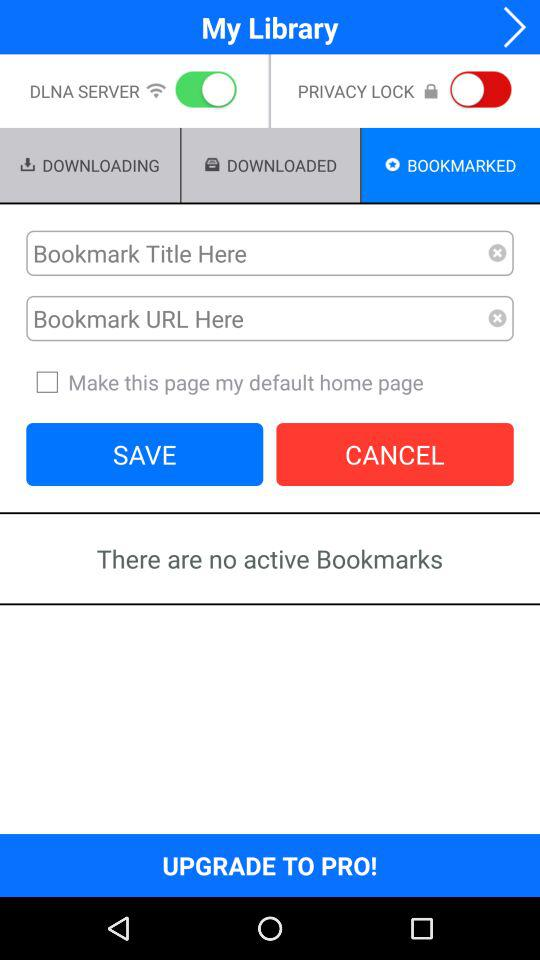What is the status of the "Make this page my default home page"? The status of the "Make this page my default home page" is "off". 